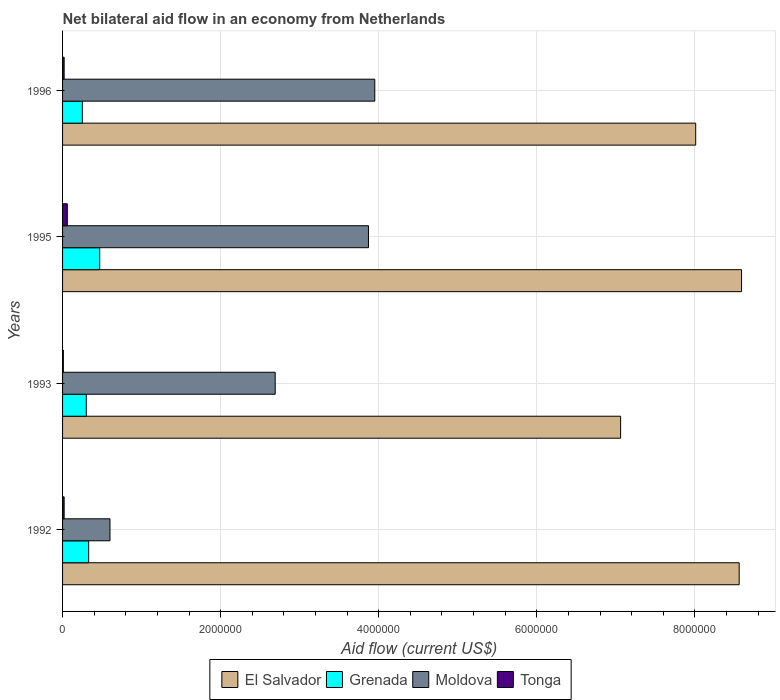How many different coloured bars are there?
Make the answer very short. 4. How many groups of bars are there?
Keep it short and to the point. 4. Are the number of bars per tick equal to the number of legend labels?
Keep it short and to the point. Yes. Are the number of bars on each tick of the Y-axis equal?
Provide a short and direct response. Yes. How many bars are there on the 4th tick from the top?
Offer a very short reply. 4. How many bars are there on the 2nd tick from the bottom?
Your answer should be compact. 4. In how many cases, is the number of bars for a given year not equal to the number of legend labels?
Give a very brief answer. 0. What is the net bilateral aid flow in Tonga in 1992?
Offer a very short reply. 2.00e+04. Across all years, what is the maximum net bilateral aid flow in Grenada?
Make the answer very short. 4.70e+05. Across all years, what is the minimum net bilateral aid flow in El Salvador?
Ensure brevity in your answer.  7.06e+06. In which year was the net bilateral aid flow in Grenada minimum?
Provide a succinct answer. 1996. What is the total net bilateral aid flow in Tonga in the graph?
Keep it short and to the point. 1.10e+05. What is the average net bilateral aid flow in El Salvador per year?
Offer a terse response. 8.06e+06. In the year 1995, what is the difference between the net bilateral aid flow in Tonga and net bilateral aid flow in Grenada?
Offer a terse response. -4.10e+05. What is the ratio of the net bilateral aid flow in Tonga in 1993 to that in 1996?
Provide a succinct answer. 0.5. What is the difference between the highest and the lowest net bilateral aid flow in El Salvador?
Give a very brief answer. 1.53e+06. Is the sum of the net bilateral aid flow in El Salvador in 1993 and 1995 greater than the maximum net bilateral aid flow in Moldova across all years?
Your answer should be compact. Yes. Is it the case that in every year, the sum of the net bilateral aid flow in El Salvador and net bilateral aid flow in Tonga is greater than the sum of net bilateral aid flow in Moldova and net bilateral aid flow in Grenada?
Make the answer very short. Yes. What does the 4th bar from the top in 1996 represents?
Provide a short and direct response. El Salvador. What does the 4th bar from the bottom in 1993 represents?
Provide a short and direct response. Tonga. How many bars are there?
Make the answer very short. 16. Are all the bars in the graph horizontal?
Provide a short and direct response. Yes. Are the values on the major ticks of X-axis written in scientific E-notation?
Offer a terse response. No. Does the graph contain any zero values?
Keep it short and to the point. No. Does the graph contain grids?
Your answer should be compact. Yes. Where does the legend appear in the graph?
Offer a very short reply. Bottom center. How many legend labels are there?
Keep it short and to the point. 4. What is the title of the graph?
Offer a very short reply. Net bilateral aid flow in an economy from Netherlands. Does "Luxembourg" appear as one of the legend labels in the graph?
Your answer should be very brief. No. What is the label or title of the X-axis?
Give a very brief answer. Aid flow (current US$). What is the Aid flow (current US$) in El Salvador in 1992?
Your response must be concise. 8.56e+06. What is the Aid flow (current US$) of Grenada in 1992?
Your response must be concise. 3.30e+05. What is the Aid flow (current US$) of Moldova in 1992?
Give a very brief answer. 6.00e+05. What is the Aid flow (current US$) of Tonga in 1992?
Your response must be concise. 2.00e+04. What is the Aid flow (current US$) in El Salvador in 1993?
Your response must be concise. 7.06e+06. What is the Aid flow (current US$) in Moldova in 1993?
Offer a terse response. 2.69e+06. What is the Aid flow (current US$) in El Salvador in 1995?
Provide a succinct answer. 8.59e+06. What is the Aid flow (current US$) of Moldova in 1995?
Your answer should be very brief. 3.87e+06. What is the Aid flow (current US$) in El Salvador in 1996?
Provide a short and direct response. 8.01e+06. What is the Aid flow (current US$) of Grenada in 1996?
Offer a terse response. 2.50e+05. What is the Aid flow (current US$) in Moldova in 1996?
Offer a very short reply. 3.95e+06. Across all years, what is the maximum Aid flow (current US$) of El Salvador?
Your response must be concise. 8.59e+06. Across all years, what is the maximum Aid flow (current US$) of Moldova?
Ensure brevity in your answer.  3.95e+06. Across all years, what is the maximum Aid flow (current US$) in Tonga?
Keep it short and to the point. 6.00e+04. Across all years, what is the minimum Aid flow (current US$) of El Salvador?
Ensure brevity in your answer.  7.06e+06. Across all years, what is the minimum Aid flow (current US$) in Grenada?
Give a very brief answer. 2.50e+05. What is the total Aid flow (current US$) of El Salvador in the graph?
Give a very brief answer. 3.22e+07. What is the total Aid flow (current US$) in Grenada in the graph?
Make the answer very short. 1.35e+06. What is the total Aid flow (current US$) of Moldova in the graph?
Give a very brief answer. 1.11e+07. What is the total Aid flow (current US$) of Tonga in the graph?
Keep it short and to the point. 1.10e+05. What is the difference between the Aid flow (current US$) of El Salvador in 1992 and that in 1993?
Ensure brevity in your answer.  1.50e+06. What is the difference between the Aid flow (current US$) in Moldova in 1992 and that in 1993?
Keep it short and to the point. -2.09e+06. What is the difference between the Aid flow (current US$) in Grenada in 1992 and that in 1995?
Make the answer very short. -1.40e+05. What is the difference between the Aid flow (current US$) in Moldova in 1992 and that in 1995?
Provide a short and direct response. -3.27e+06. What is the difference between the Aid flow (current US$) of Tonga in 1992 and that in 1995?
Offer a very short reply. -4.00e+04. What is the difference between the Aid flow (current US$) in Grenada in 1992 and that in 1996?
Offer a terse response. 8.00e+04. What is the difference between the Aid flow (current US$) of Moldova in 1992 and that in 1996?
Ensure brevity in your answer.  -3.35e+06. What is the difference between the Aid flow (current US$) of El Salvador in 1993 and that in 1995?
Provide a succinct answer. -1.53e+06. What is the difference between the Aid flow (current US$) in Moldova in 1993 and that in 1995?
Provide a short and direct response. -1.18e+06. What is the difference between the Aid flow (current US$) of El Salvador in 1993 and that in 1996?
Offer a very short reply. -9.50e+05. What is the difference between the Aid flow (current US$) in Grenada in 1993 and that in 1996?
Provide a succinct answer. 5.00e+04. What is the difference between the Aid flow (current US$) in Moldova in 1993 and that in 1996?
Ensure brevity in your answer.  -1.26e+06. What is the difference between the Aid flow (current US$) of El Salvador in 1995 and that in 1996?
Provide a short and direct response. 5.80e+05. What is the difference between the Aid flow (current US$) of Grenada in 1995 and that in 1996?
Offer a terse response. 2.20e+05. What is the difference between the Aid flow (current US$) in El Salvador in 1992 and the Aid flow (current US$) in Grenada in 1993?
Provide a short and direct response. 8.26e+06. What is the difference between the Aid flow (current US$) in El Salvador in 1992 and the Aid flow (current US$) in Moldova in 1993?
Provide a succinct answer. 5.87e+06. What is the difference between the Aid flow (current US$) of El Salvador in 1992 and the Aid flow (current US$) of Tonga in 1993?
Offer a terse response. 8.55e+06. What is the difference between the Aid flow (current US$) of Grenada in 1992 and the Aid flow (current US$) of Moldova in 1993?
Provide a succinct answer. -2.36e+06. What is the difference between the Aid flow (current US$) in Grenada in 1992 and the Aid flow (current US$) in Tonga in 1993?
Your answer should be compact. 3.20e+05. What is the difference between the Aid flow (current US$) in Moldova in 1992 and the Aid flow (current US$) in Tonga in 1993?
Offer a very short reply. 5.90e+05. What is the difference between the Aid flow (current US$) of El Salvador in 1992 and the Aid flow (current US$) of Grenada in 1995?
Provide a short and direct response. 8.09e+06. What is the difference between the Aid flow (current US$) of El Salvador in 1992 and the Aid flow (current US$) of Moldova in 1995?
Keep it short and to the point. 4.69e+06. What is the difference between the Aid flow (current US$) of El Salvador in 1992 and the Aid flow (current US$) of Tonga in 1995?
Offer a terse response. 8.50e+06. What is the difference between the Aid flow (current US$) in Grenada in 1992 and the Aid flow (current US$) in Moldova in 1995?
Provide a succinct answer. -3.54e+06. What is the difference between the Aid flow (current US$) of Moldova in 1992 and the Aid flow (current US$) of Tonga in 1995?
Offer a very short reply. 5.40e+05. What is the difference between the Aid flow (current US$) of El Salvador in 1992 and the Aid flow (current US$) of Grenada in 1996?
Provide a short and direct response. 8.31e+06. What is the difference between the Aid flow (current US$) of El Salvador in 1992 and the Aid flow (current US$) of Moldova in 1996?
Offer a terse response. 4.61e+06. What is the difference between the Aid flow (current US$) of El Salvador in 1992 and the Aid flow (current US$) of Tonga in 1996?
Ensure brevity in your answer.  8.54e+06. What is the difference between the Aid flow (current US$) of Grenada in 1992 and the Aid flow (current US$) of Moldova in 1996?
Keep it short and to the point. -3.62e+06. What is the difference between the Aid flow (current US$) in Moldova in 1992 and the Aid flow (current US$) in Tonga in 1996?
Your answer should be very brief. 5.80e+05. What is the difference between the Aid flow (current US$) in El Salvador in 1993 and the Aid flow (current US$) in Grenada in 1995?
Provide a short and direct response. 6.59e+06. What is the difference between the Aid flow (current US$) in El Salvador in 1993 and the Aid flow (current US$) in Moldova in 1995?
Provide a short and direct response. 3.19e+06. What is the difference between the Aid flow (current US$) of El Salvador in 1993 and the Aid flow (current US$) of Tonga in 1995?
Offer a very short reply. 7.00e+06. What is the difference between the Aid flow (current US$) in Grenada in 1993 and the Aid flow (current US$) in Moldova in 1995?
Give a very brief answer. -3.57e+06. What is the difference between the Aid flow (current US$) in Moldova in 1993 and the Aid flow (current US$) in Tonga in 1995?
Your answer should be compact. 2.63e+06. What is the difference between the Aid flow (current US$) of El Salvador in 1993 and the Aid flow (current US$) of Grenada in 1996?
Ensure brevity in your answer.  6.81e+06. What is the difference between the Aid flow (current US$) of El Salvador in 1993 and the Aid flow (current US$) of Moldova in 1996?
Provide a succinct answer. 3.11e+06. What is the difference between the Aid flow (current US$) in El Salvador in 1993 and the Aid flow (current US$) in Tonga in 1996?
Ensure brevity in your answer.  7.04e+06. What is the difference between the Aid flow (current US$) of Grenada in 1993 and the Aid flow (current US$) of Moldova in 1996?
Offer a very short reply. -3.65e+06. What is the difference between the Aid flow (current US$) in Moldova in 1993 and the Aid flow (current US$) in Tonga in 1996?
Your answer should be very brief. 2.67e+06. What is the difference between the Aid flow (current US$) of El Salvador in 1995 and the Aid flow (current US$) of Grenada in 1996?
Keep it short and to the point. 8.34e+06. What is the difference between the Aid flow (current US$) of El Salvador in 1995 and the Aid flow (current US$) of Moldova in 1996?
Provide a succinct answer. 4.64e+06. What is the difference between the Aid flow (current US$) of El Salvador in 1995 and the Aid flow (current US$) of Tonga in 1996?
Provide a short and direct response. 8.57e+06. What is the difference between the Aid flow (current US$) in Grenada in 1995 and the Aid flow (current US$) in Moldova in 1996?
Make the answer very short. -3.48e+06. What is the difference between the Aid flow (current US$) of Moldova in 1995 and the Aid flow (current US$) of Tonga in 1996?
Give a very brief answer. 3.85e+06. What is the average Aid flow (current US$) in El Salvador per year?
Offer a very short reply. 8.06e+06. What is the average Aid flow (current US$) of Grenada per year?
Your answer should be compact. 3.38e+05. What is the average Aid flow (current US$) of Moldova per year?
Ensure brevity in your answer.  2.78e+06. What is the average Aid flow (current US$) of Tonga per year?
Ensure brevity in your answer.  2.75e+04. In the year 1992, what is the difference between the Aid flow (current US$) of El Salvador and Aid flow (current US$) of Grenada?
Provide a short and direct response. 8.23e+06. In the year 1992, what is the difference between the Aid flow (current US$) in El Salvador and Aid flow (current US$) in Moldova?
Make the answer very short. 7.96e+06. In the year 1992, what is the difference between the Aid flow (current US$) in El Salvador and Aid flow (current US$) in Tonga?
Your answer should be very brief. 8.54e+06. In the year 1992, what is the difference between the Aid flow (current US$) of Moldova and Aid flow (current US$) of Tonga?
Offer a very short reply. 5.80e+05. In the year 1993, what is the difference between the Aid flow (current US$) in El Salvador and Aid flow (current US$) in Grenada?
Offer a terse response. 6.76e+06. In the year 1993, what is the difference between the Aid flow (current US$) in El Salvador and Aid flow (current US$) in Moldova?
Keep it short and to the point. 4.37e+06. In the year 1993, what is the difference between the Aid flow (current US$) in El Salvador and Aid flow (current US$) in Tonga?
Your answer should be very brief. 7.05e+06. In the year 1993, what is the difference between the Aid flow (current US$) in Grenada and Aid flow (current US$) in Moldova?
Ensure brevity in your answer.  -2.39e+06. In the year 1993, what is the difference between the Aid flow (current US$) of Grenada and Aid flow (current US$) of Tonga?
Provide a succinct answer. 2.90e+05. In the year 1993, what is the difference between the Aid flow (current US$) in Moldova and Aid flow (current US$) in Tonga?
Your response must be concise. 2.68e+06. In the year 1995, what is the difference between the Aid flow (current US$) in El Salvador and Aid flow (current US$) in Grenada?
Make the answer very short. 8.12e+06. In the year 1995, what is the difference between the Aid flow (current US$) of El Salvador and Aid flow (current US$) of Moldova?
Provide a succinct answer. 4.72e+06. In the year 1995, what is the difference between the Aid flow (current US$) in El Salvador and Aid flow (current US$) in Tonga?
Ensure brevity in your answer.  8.53e+06. In the year 1995, what is the difference between the Aid flow (current US$) of Grenada and Aid flow (current US$) of Moldova?
Give a very brief answer. -3.40e+06. In the year 1995, what is the difference between the Aid flow (current US$) in Moldova and Aid flow (current US$) in Tonga?
Provide a succinct answer. 3.81e+06. In the year 1996, what is the difference between the Aid flow (current US$) of El Salvador and Aid flow (current US$) of Grenada?
Your answer should be very brief. 7.76e+06. In the year 1996, what is the difference between the Aid flow (current US$) of El Salvador and Aid flow (current US$) of Moldova?
Your response must be concise. 4.06e+06. In the year 1996, what is the difference between the Aid flow (current US$) of El Salvador and Aid flow (current US$) of Tonga?
Provide a short and direct response. 7.99e+06. In the year 1996, what is the difference between the Aid flow (current US$) of Grenada and Aid flow (current US$) of Moldova?
Keep it short and to the point. -3.70e+06. In the year 1996, what is the difference between the Aid flow (current US$) in Moldova and Aid flow (current US$) in Tonga?
Your response must be concise. 3.93e+06. What is the ratio of the Aid flow (current US$) in El Salvador in 1992 to that in 1993?
Ensure brevity in your answer.  1.21. What is the ratio of the Aid flow (current US$) of Moldova in 1992 to that in 1993?
Your answer should be very brief. 0.22. What is the ratio of the Aid flow (current US$) in Grenada in 1992 to that in 1995?
Offer a terse response. 0.7. What is the ratio of the Aid flow (current US$) of Moldova in 1992 to that in 1995?
Ensure brevity in your answer.  0.15. What is the ratio of the Aid flow (current US$) in Tonga in 1992 to that in 1995?
Your answer should be compact. 0.33. What is the ratio of the Aid flow (current US$) of El Salvador in 1992 to that in 1996?
Provide a short and direct response. 1.07. What is the ratio of the Aid flow (current US$) of Grenada in 1992 to that in 1996?
Your response must be concise. 1.32. What is the ratio of the Aid flow (current US$) in Moldova in 1992 to that in 1996?
Ensure brevity in your answer.  0.15. What is the ratio of the Aid flow (current US$) of El Salvador in 1993 to that in 1995?
Ensure brevity in your answer.  0.82. What is the ratio of the Aid flow (current US$) in Grenada in 1993 to that in 1995?
Provide a succinct answer. 0.64. What is the ratio of the Aid flow (current US$) of Moldova in 1993 to that in 1995?
Provide a succinct answer. 0.7. What is the ratio of the Aid flow (current US$) of Tonga in 1993 to that in 1995?
Give a very brief answer. 0.17. What is the ratio of the Aid flow (current US$) of El Salvador in 1993 to that in 1996?
Provide a short and direct response. 0.88. What is the ratio of the Aid flow (current US$) in Grenada in 1993 to that in 1996?
Make the answer very short. 1.2. What is the ratio of the Aid flow (current US$) of Moldova in 1993 to that in 1996?
Your response must be concise. 0.68. What is the ratio of the Aid flow (current US$) in Tonga in 1993 to that in 1996?
Give a very brief answer. 0.5. What is the ratio of the Aid flow (current US$) of El Salvador in 1995 to that in 1996?
Offer a very short reply. 1.07. What is the ratio of the Aid flow (current US$) in Grenada in 1995 to that in 1996?
Offer a very short reply. 1.88. What is the ratio of the Aid flow (current US$) in Moldova in 1995 to that in 1996?
Provide a succinct answer. 0.98. What is the difference between the highest and the second highest Aid flow (current US$) of Tonga?
Provide a short and direct response. 4.00e+04. What is the difference between the highest and the lowest Aid flow (current US$) of El Salvador?
Your answer should be compact. 1.53e+06. What is the difference between the highest and the lowest Aid flow (current US$) of Moldova?
Provide a short and direct response. 3.35e+06. What is the difference between the highest and the lowest Aid flow (current US$) of Tonga?
Your answer should be compact. 5.00e+04. 